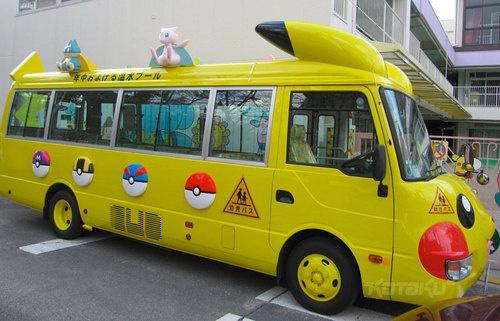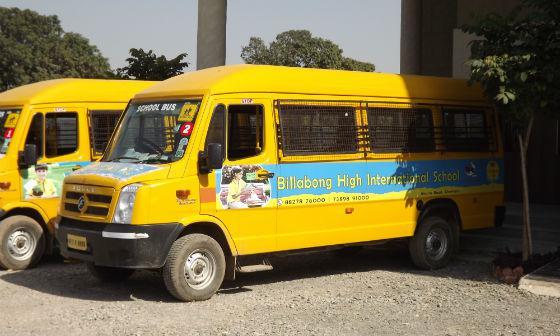The first image is the image on the left, the second image is the image on the right. Analyze the images presented: Is the assertion "One bus has cartoon characters on the roof." valid? Answer yes or no. Yes. The first image is the image on the left, the second image is the image on the right. For the images shown, is this caption "A bus with sculpted cartoon characters across the top is visible." true? Answer yes or no. Yes. 